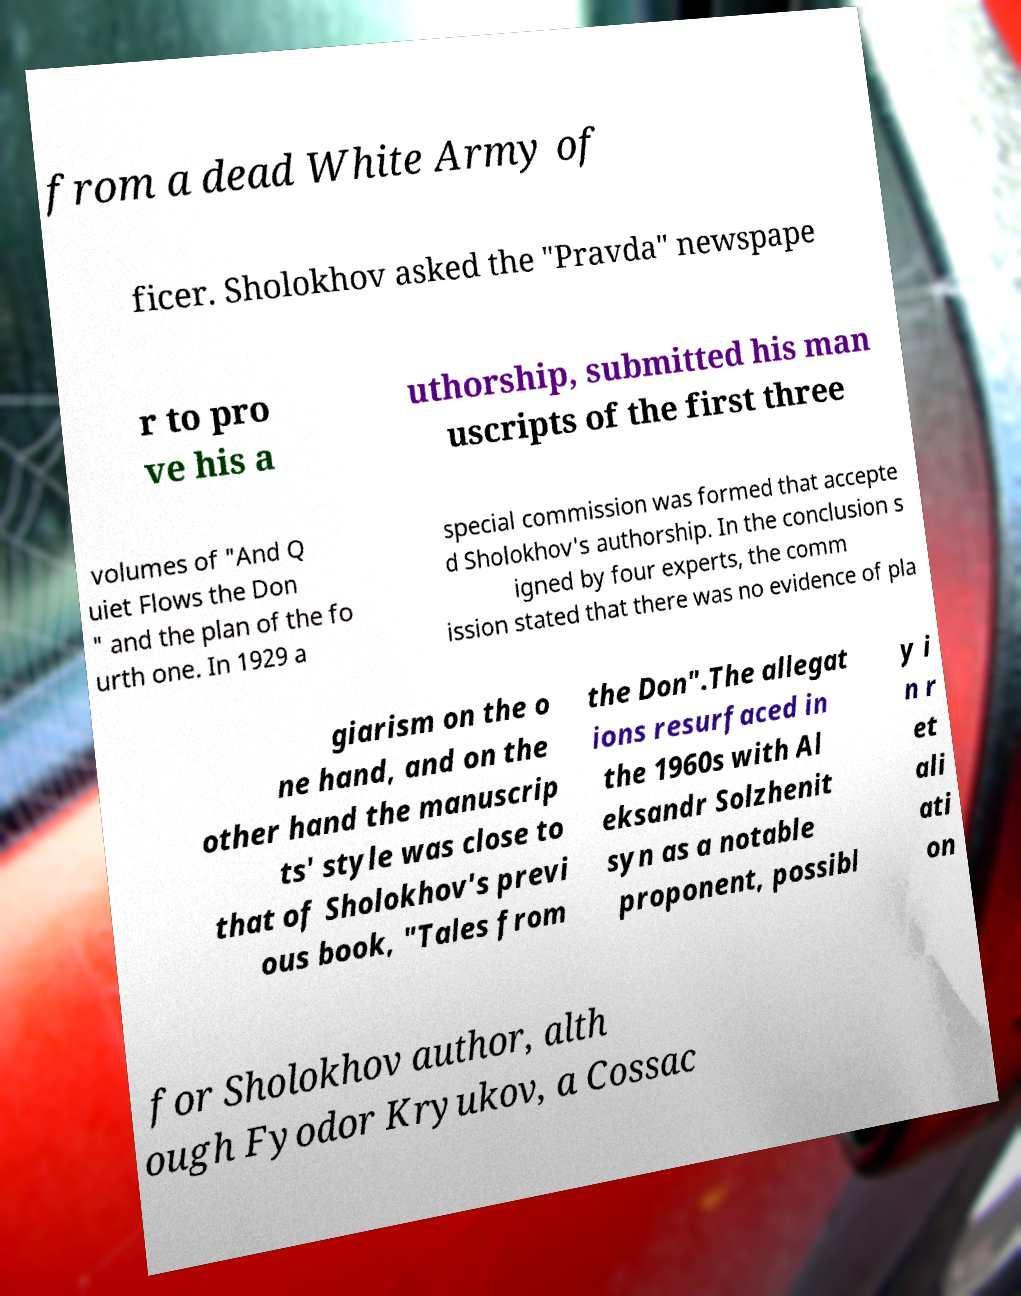There's text embedded in this image that I need extracted. Can you transcribe it verbatim? from a dead White Army of ficer. Sholokhov asked the "Pravda" newspape r to pro ve his a uthorship, submitted his man uscripts of the first three volumes of "And Q uiet Flows the Don " and the plan of the fo urth one. In 1929 a special commission was formed that accepte d Sholokhov's authorship. In the conclusion s igned by four experts, the comm ission stated that there was no evidence of pla giarism on the o ne hand, and on the other hand the manuscrip ts' style was close to that of Sholokhov's previ ous book, "Tales from the Don".The allegat ions resurfaced in the 1960s with Al eksandr Solzhenit syn as a notable proponent, possibl y i n r et ali ati on for Sholokhov author, alth ough Fyodor Kryukov, a Cossac 